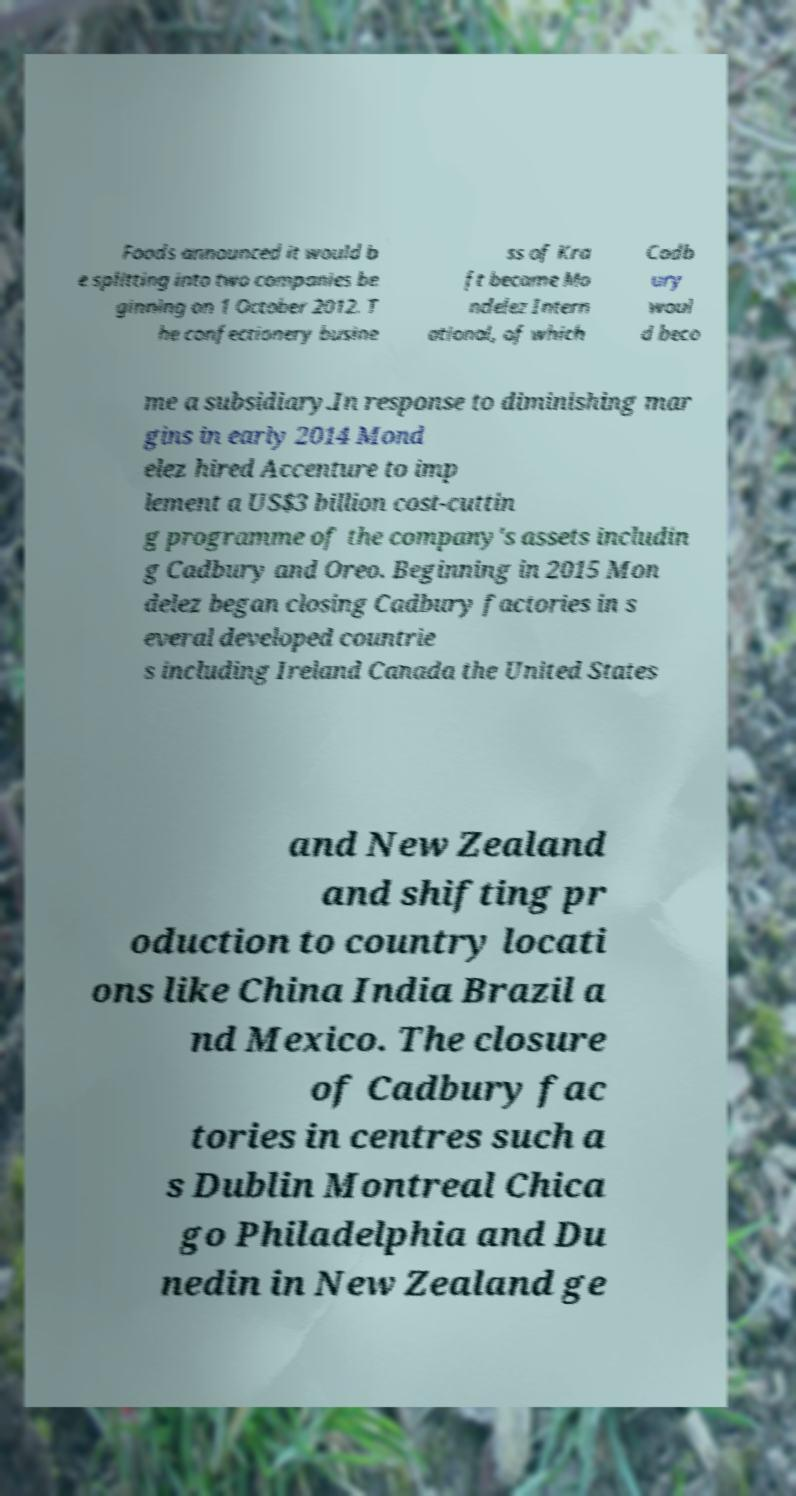For documentation purposes, I need the text within this image transcribed. Could you provide that? Foods announced it would b e splitting into two companies be ginning on 1 October 2012. T he confectionery busine ss of Kra ft became Mo ndelez Intern ational, of which Cadb ury woul d beco me a subsidiary.In response to diminishing mar gins in early 2014 Mond elez hired Accenture to imp lement a US$3 billion cost-cuttin g programme of the company's assets includin g Cadbury and Oreo. Beginning in 2015 Mon delez began closing Cadbury factories in s everal developed countrie s including Ireland Canada the United States and New Zealand and shifting pr oduction to country locati ons like China India Brazil a nd Mexico. The closure of Cadbury fac tories in centres such a s Dublin Montreal Chica go Philadelphia and Du nedin in New Zealand ge 